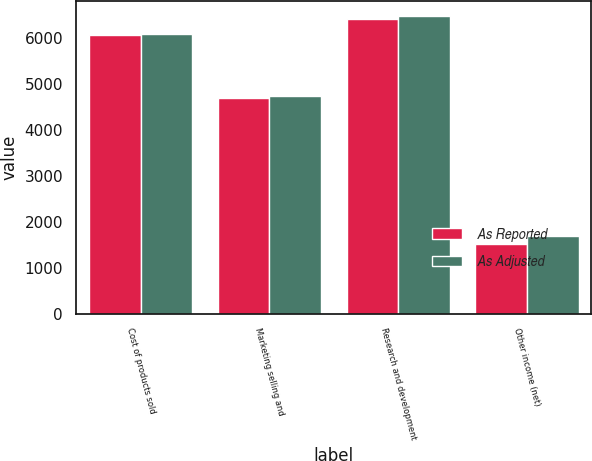Convert chart to OTSL. <chart><loc_0><loc_0><loc_500><loc_500><stacked_bar_chart><ecel><fcel>Cost of products sold<fcel>Marketing selling and<fcel>Research and development<fcel>Other income (net)<nl><fcel>As Reported<fcel>6066<fcel>4687<fcel>6411<fcel>1519<nl><fcel>As Adjusted<fcel>6094<fcel>4751<fcel>6482<fcel>1682<nl></chart> 